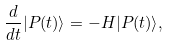<formula> <loc_0><loc_0><loc_500><loc_500>\frac { d } { d t } | P ( t ) \rangle = - H | P ( t ) \rangle ,</formula> 